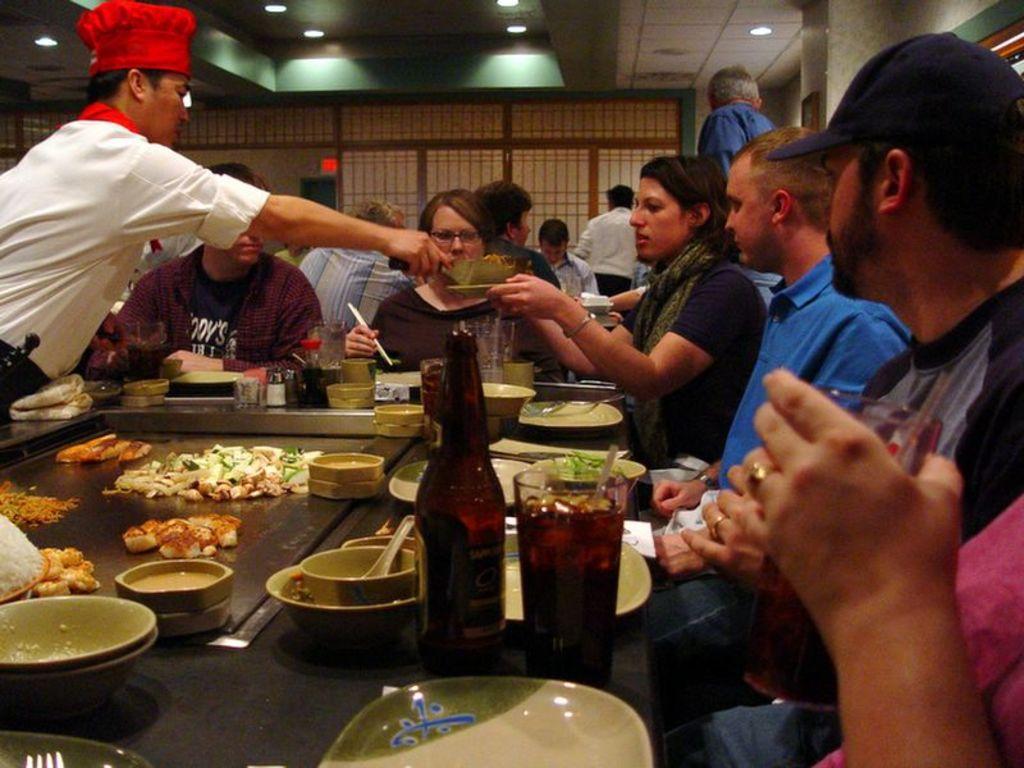Please provide a concise description of this image. In the picture we can see a restaurant with a table and food items on it and around it we can see some people are sitting and one person is serving a food on the plate and he is with red cap and white shirt and in the background we can see a wall and to the ceiling we can see the lights. 